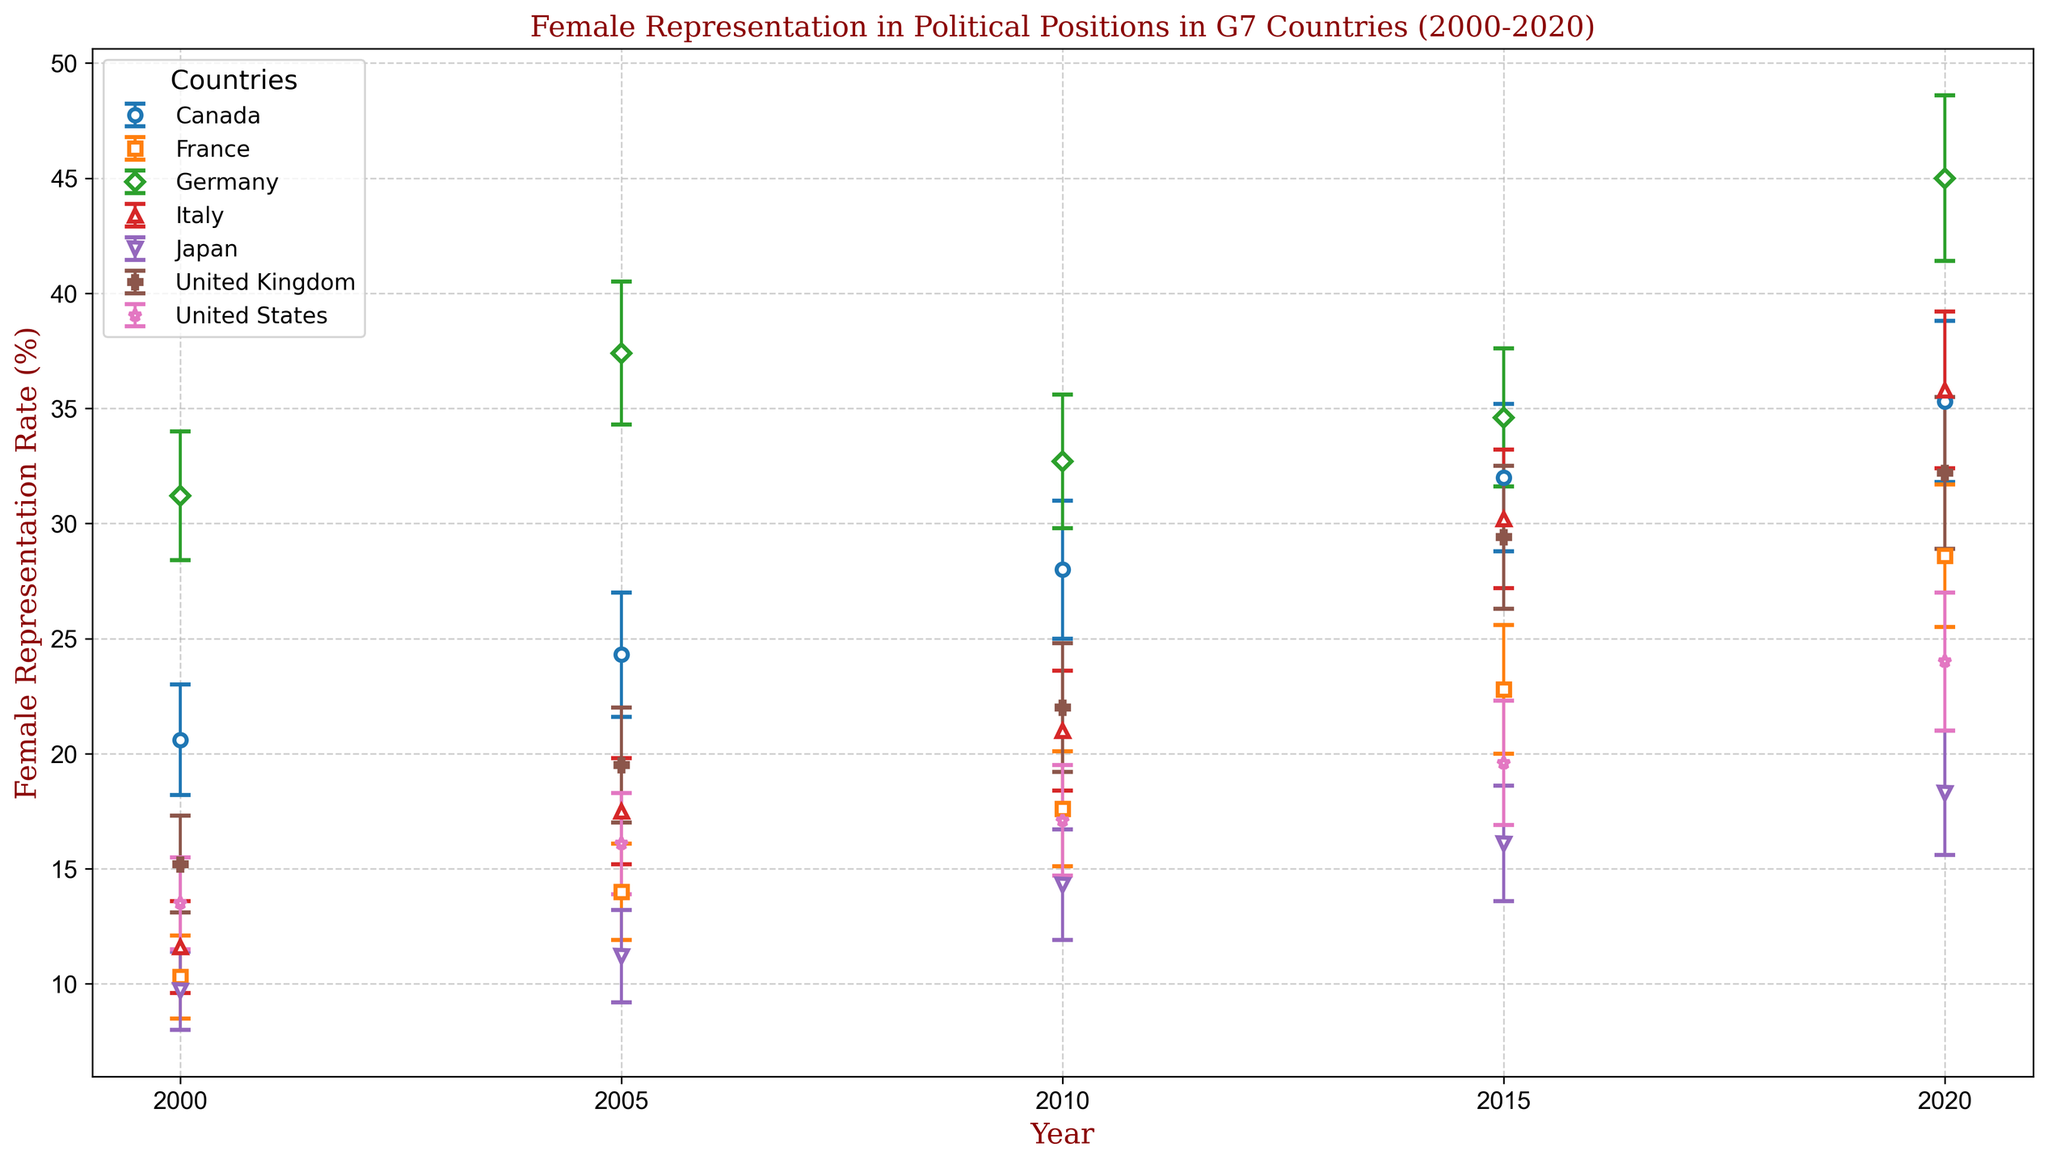What is the highest female representation rate observed in 2020 among the G7 countries? Germany has the highest female representation rate in 2020. By visually examining the error bar plot, Germany's point for 2020 is higher than the points of other countries for the same year.
Answer: 45.0% Between 2000 and 2020, which country shows the most significant increase in female representation in political positions? By comparing the difference between the rates of 2020 and 2000 for each country, Germany's increase (45.0% - 31.2% = 13.8%) is the highest.
Answer: Germany In 2005, which country had the lowest female representation rate in political positions? By looking at the plotted points for each country in 2005, Japan has the lowest rate.
Answer: Japan What is the average female representation rate in the G7 countries in 2010? The rates in 2010 are: Canada (28.0), France (17.6), Germany (32.7), Italy (21.0), Japan (14.3), United Kingdom (22.0), United States (17.1). The average is calculated as (28.0 + 17.6 + 32.7 + 21.0 + 14.3 + 22.0 + 17.1) / 7 = 22.38%.
Answer: 22.38% Which G7 country had the closest female representation rate to 30% in 2015? By examining the female representation rates in 2015: Canada (32.0), France (22.8), Germany (34.6), Italy (30.2), Japan (16.1), United Kingdom (29.4), and United States (19.6), Italy's rate (30.2%) is the closest to 30%.
Answer: Italy Compare the trend of female representation rates in Japan and the United States between 2000 and 2020. Which country shows a more consistent increase? Both countries show an increasing trend, but Japan's increase is more gradual with smaller increments over the years, whereas the United States shows a more fluctuating pattern. Hence, Japan's increase is more consistent.
Answer: Japan In which year did France surpass a 20% female representation rate for the first time, and by how much did it exceed this threshold? France surpassed 20% in 2015 with a rate of 22.8%. The amount exceeding the threshold is 22.8% - 20% = 2.8%.
Answer: 2015, 2.8% What is the standard deviation of the female representation rate for Canada and Germany in 2020? From the plot, the standard deviations in 2020 are 3.5% for Canada and 3.6% for Germany. These can be read from the error bars extending above and below the data points.
Answer: Canada: 3.5%, Germany: 3.6% In 2000, how do the female representation rates of Italy and Japan compare? Italy's rate in 2000 is 11.6% and Japan's rate is 9.7%. By comparison, Italy has a higher rate.
Answer: Italy Calculate the overall change in female representation rate for the United Kingdom from 2000 to 2020. The rate in 2000 is 15.2%, and in 2020 it is 32.2%. The overall change is 32.2% - 15.2% = 17%.
Answer: 17% 